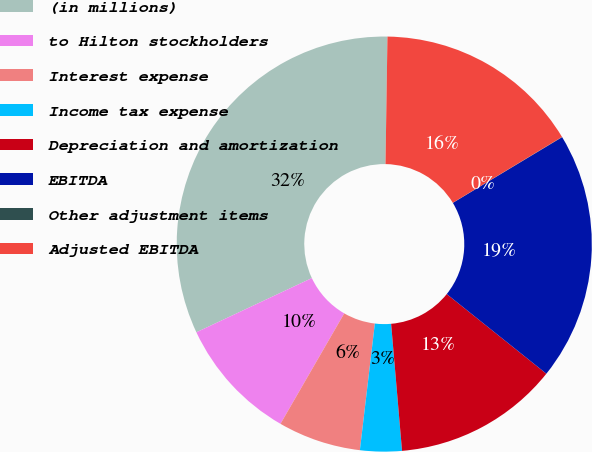Convert chart to OTSL. <chart><loc_0><loc_0><loc_500><loc_500><pie_chart><fcel>(in millions)<fcel>to Hilton stockholders<fcel>Interest expense<fcel>Income tax expense<fcel>Depreciation and amortization<fcel>EBITDA<fcel>Other adjustment items<fcel>Adjusted EBITDA<nl><fcel>32.23%<fcel>9.68%<fcel>6.46%<fcel>3.24%<fcel>12.9%<fcel>19.35%<fcel>0.02%<fcel>16.12%<nl></chart> 